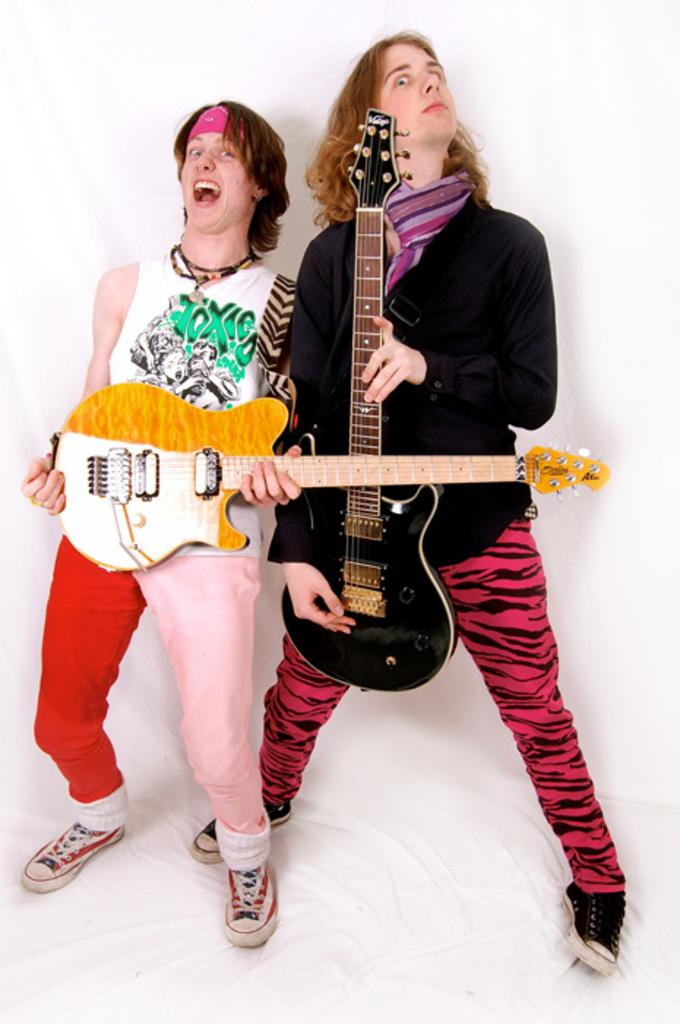How many people are in the image? There are two men in the image. What are the men holding in their hands? Each man is holding a guitar in their hands. What type of precipitation can be seen falling in the image? There is no precipitation present in the image. Are the two men in the image related as brothers? The provided facts do not mention any familial relationship between the two men. What type of writing instrument is the man on the left using in the image? There is no writing instrument, such as a quill, present in the image. 